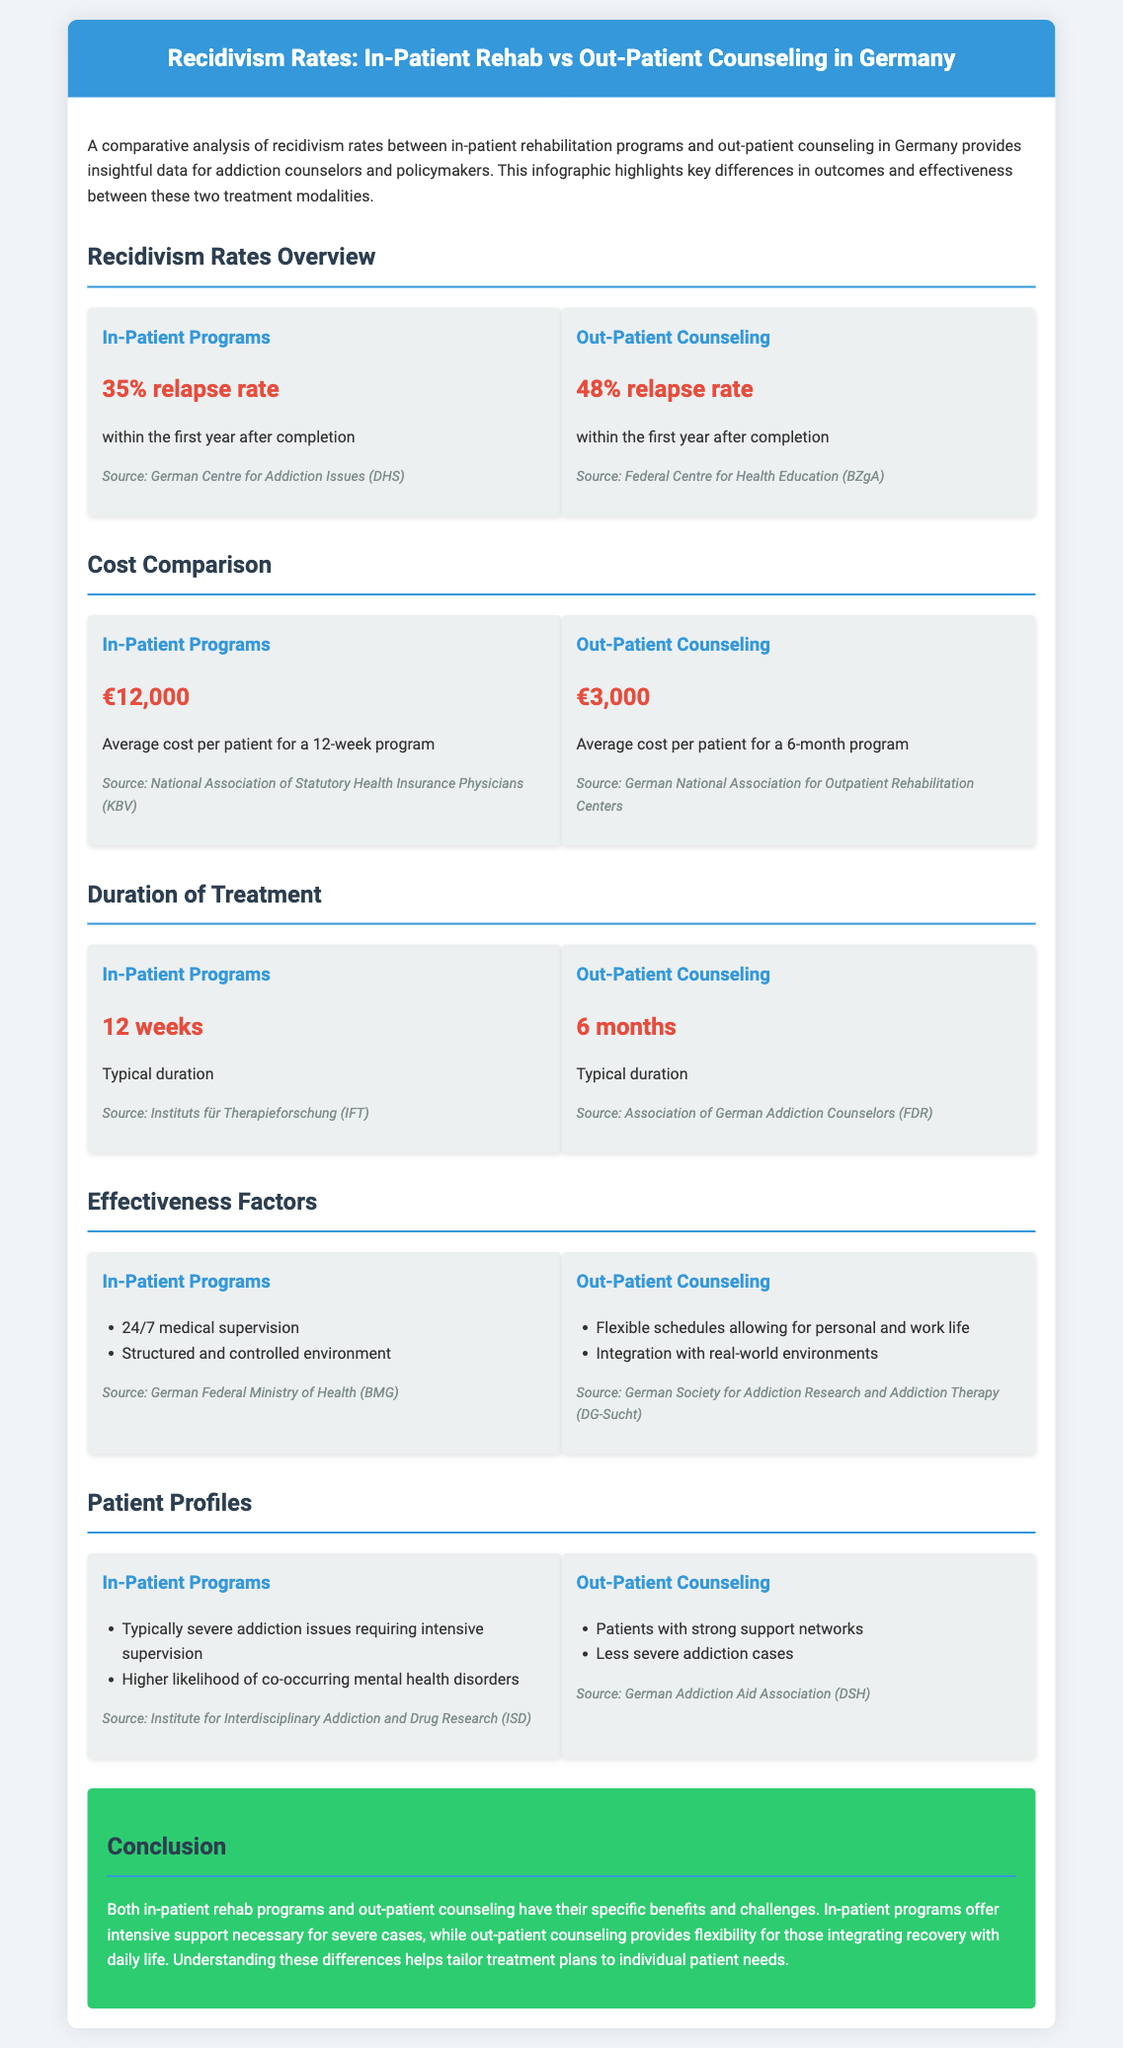What is the relapse rate for in-patient programs? The document states that the relapse rate for in-patient programs is 35%.
Answer: 35% What is the average cost of out-patient counseling? The average cost for out-patient counseling is provided in the document as €3,000.
Answer: €3,000 What is the typical duration of in-patient programs? According to the document, the typical duration of in-patient programs is 12 weeks.
Answer: 12 weeks Which treatment has a lower relapse rate? The comparison shows that in-patient programs have a lower relapse rate compared to out-patient counseling.
Answer: In-Patient Programs What are two factors that contribute to the effectiveness of in-patient programs? The document lists "24/7 medical supervision" and "Structured and controlled environment" as effectiveness factors.
Answer: 24/7 medical supervision, Structured and controlled environment How long is the typical duration of out-patient counseling? The document indicates that the typical duration of out-patient counseling is 6 months.
Answer: 6 months Which patient profile is typical for in-patient programs? The document mentions that patients in in-patient programs typically have "severe addiction issues".
Answer: Severe addiction issues What is one advantage of out-patient counseling mentioned in the document? The document states that out-patient counseling allows for "Flexible schedules allowing for personal and work life".
Answer: Flexible schedules What is the source for the relapse rate in out-patient counseling? The source for the relapse rate in out-patient counseling is the Federal Centre for Health Education (BZgA).
Answer: Federal Centre for Health Education (BZgA) 